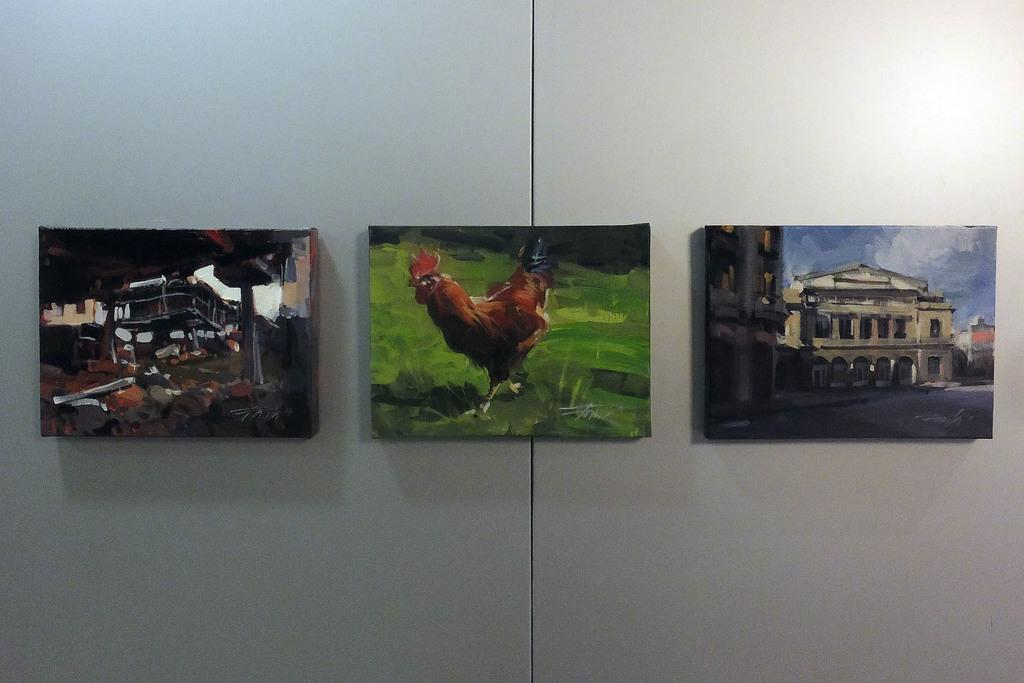How many paintings are visible in the image? There are three paintings in the image. Where are the paintings located? The paintings are on a wall. What type of linen is draped over the paintings in the image? There is no linen draped over the paintings in the image; the paintings are simply hanging on the wall. 